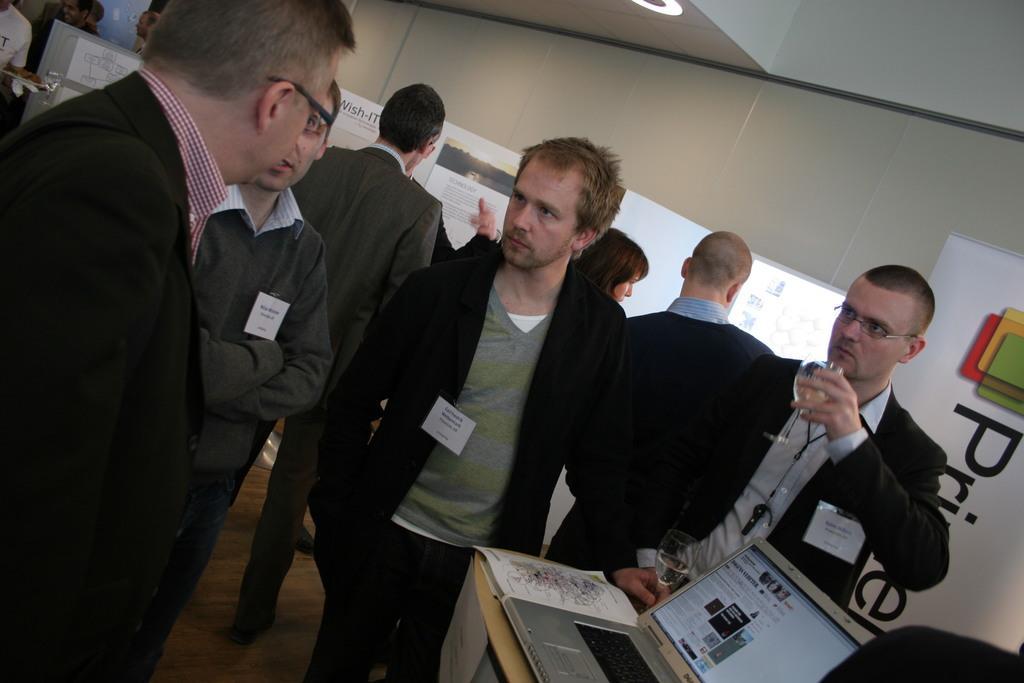Describe this image in one or two sentences. In the image we can see there are people standing, wearing clothes and some of them are wearing spectacles. The right side persons are holding a wine glass in hand. Here we can see a laptop, table, poster and a window. 